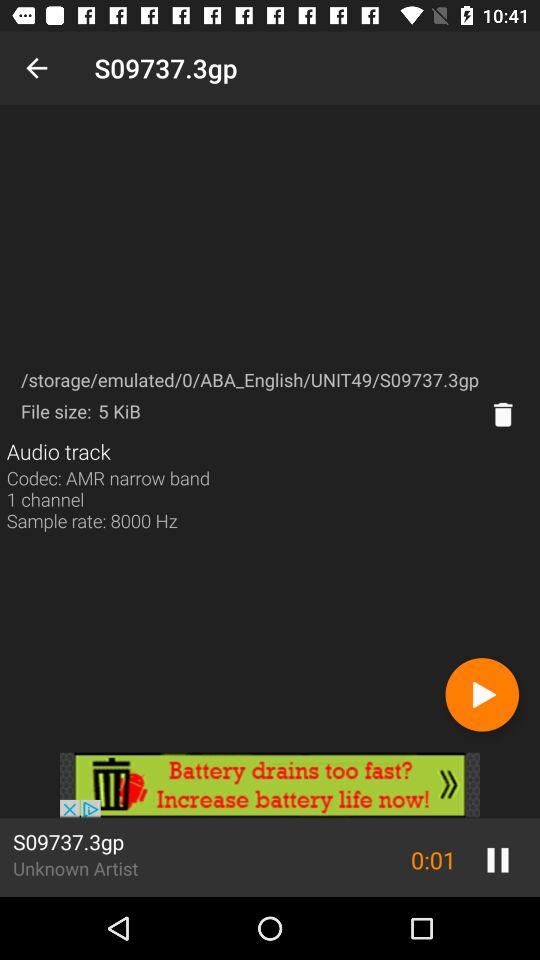What is the track name? The track name is "S09737.3gp". 